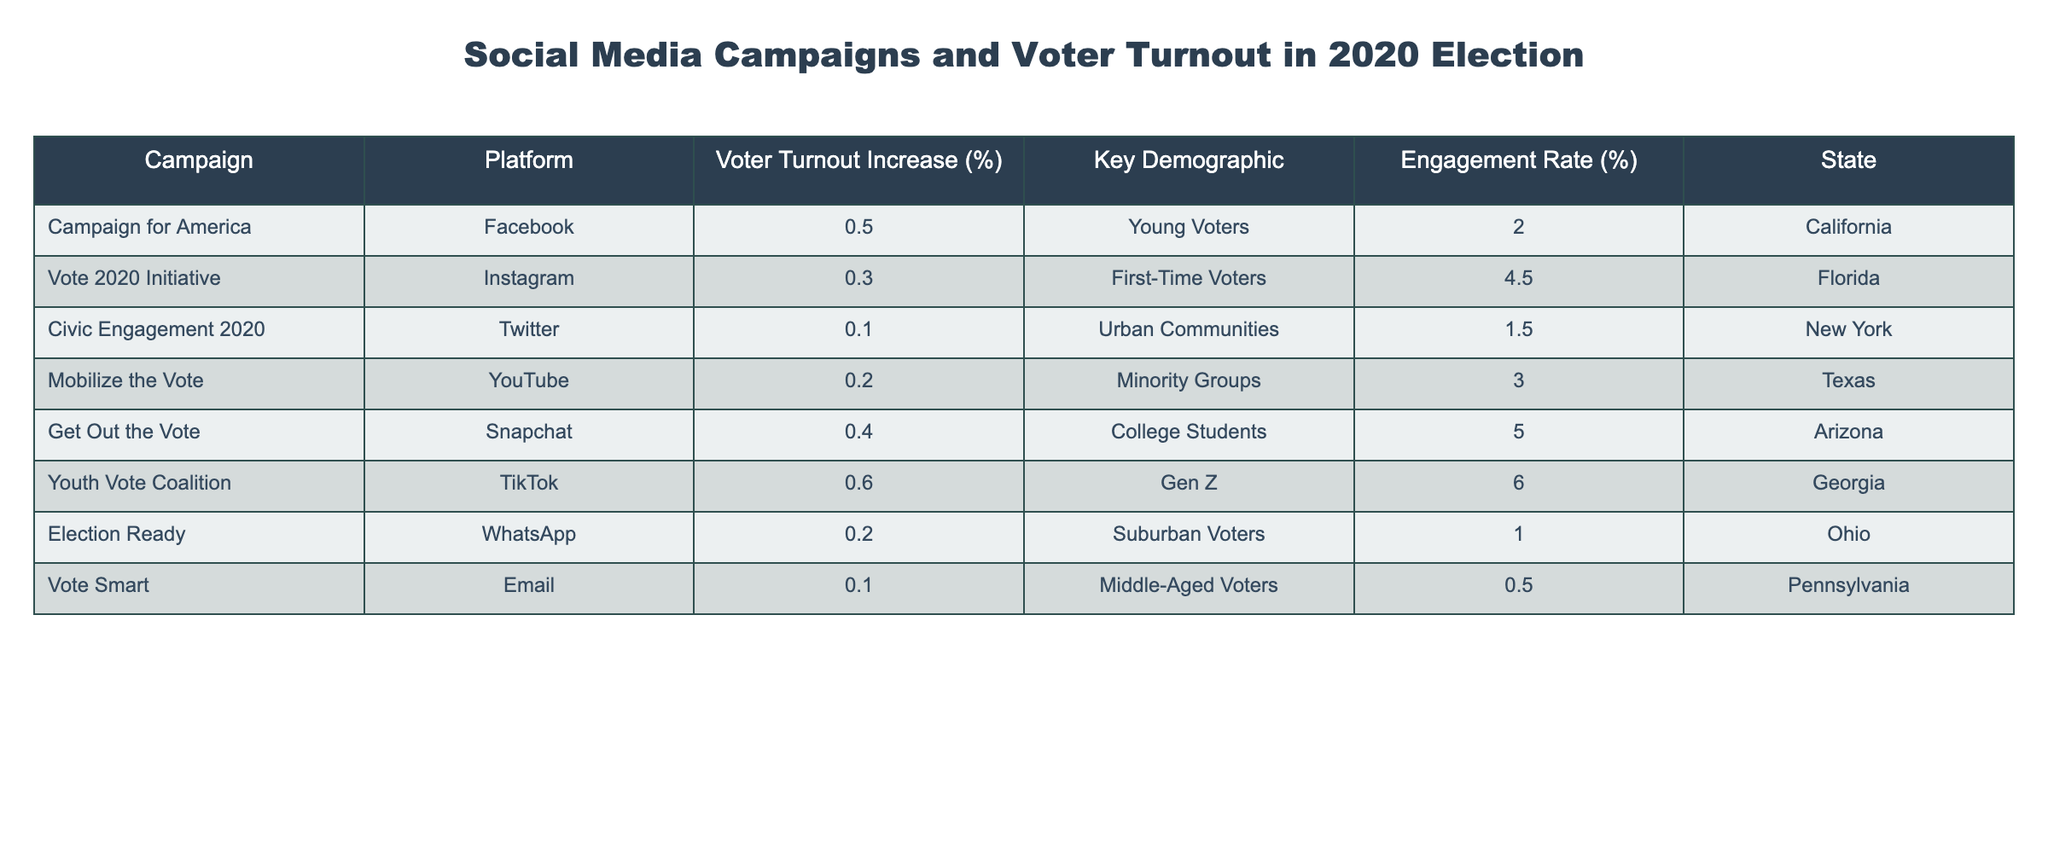What is the voter turnout increase percentage for the Youth Vote Coalition campaign? The Youth Vote Coalition campaign has a voter turnout increase percentage of 0.6, as indicated in the table.
Answer: 0.6 Which campaign had the highest engagement rate and what was that rate? The Youth Vote Coalition campaign had the highest engagement rate of 6.0%, as visible in the Engagement Rate column of the table.
Answer: 6.0 What is the average voter turnout increase percentage across all campaigns listed in the table? To find the average, sum the Voter Turnout Increase percentages: 0.5 + 0.3 + 0.1 + 0.2 + 0.4 + 0.6 + 0.2 + 0.1 = 2.4. There are 8 campaigns, so the average is 2.4/8 = 0.3.
Answer: 0.3 Did any campaign specifically target minority groups? Yes, the Mobilize the Vote campaign targeted minority groups, as stated in the Key Demographic column of the table.
Answer: Yes Which platform had the lowest voter turnout increase increase and what was the state associated with it? The campaign with the lowest voter turnout increase was Civic Engagement 2020 with a percentage of 0.1, and it was associated with New York, as shown in the corresponding rows of the table.
Answer: 0.1, New York What is the total voter turnout increase percentage from campaigns aimed at youth demographics (under 30 years)? The campaigns that aimed at youth demographics are Campaign for America (0.5), Get Out the Vote (0.4), and Youth Vote Coalition (0.6). Adding these gives 0.5 + 0.4 + 0.6 = 1.5.
Answer: 1.5 Which demographic had the highest voter turnout increase in this table? The Youth Vote Coalition targeting Gen Z had the highest voter turnout increase at 0.6%, based on the Voter Turnout Increase column and the Key Demographic column.
Answer: Gen Z Was there a campaign targeting suburban voters? Yes, the Election Ready campaign specifically targeted suburban voters as indicated in the Key Demographic column.
Answer: Yes What is the difference in engagement rates between the campaign targeting First-Time Voters and that targeting College Students? The engagement rate for Vote 2020 Initiative (targeting First-Time Voters) is 4.5, and for Get Out the Vote (targeting College Students) is 5.0. The difference is 5.0 - 4.5 = 0.5.
Answer: 0.5 